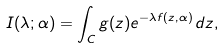Convert formula to latex. <formula><loc_0><loc_0><loc_500><loc_500>I ( \lambda ; { \alpha } ) = \int _ { C } g ( z ) e ^ { - \lambda f ( z , { \alpha } ) } \, d z ,</formula> 